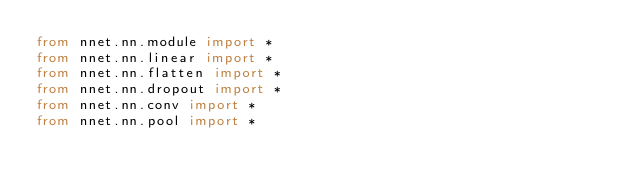Convert code to text. <code><loc_0><loc_0><loc_500><loc_500><_Python_>from nnet.nn.module import *
from nnet.nn.linear import *
from nnet.nn.flatten import *
from nnet.nn.dropout import *
from nnet.nn.conv import *
from nnet.nn.pool import *


</code> 